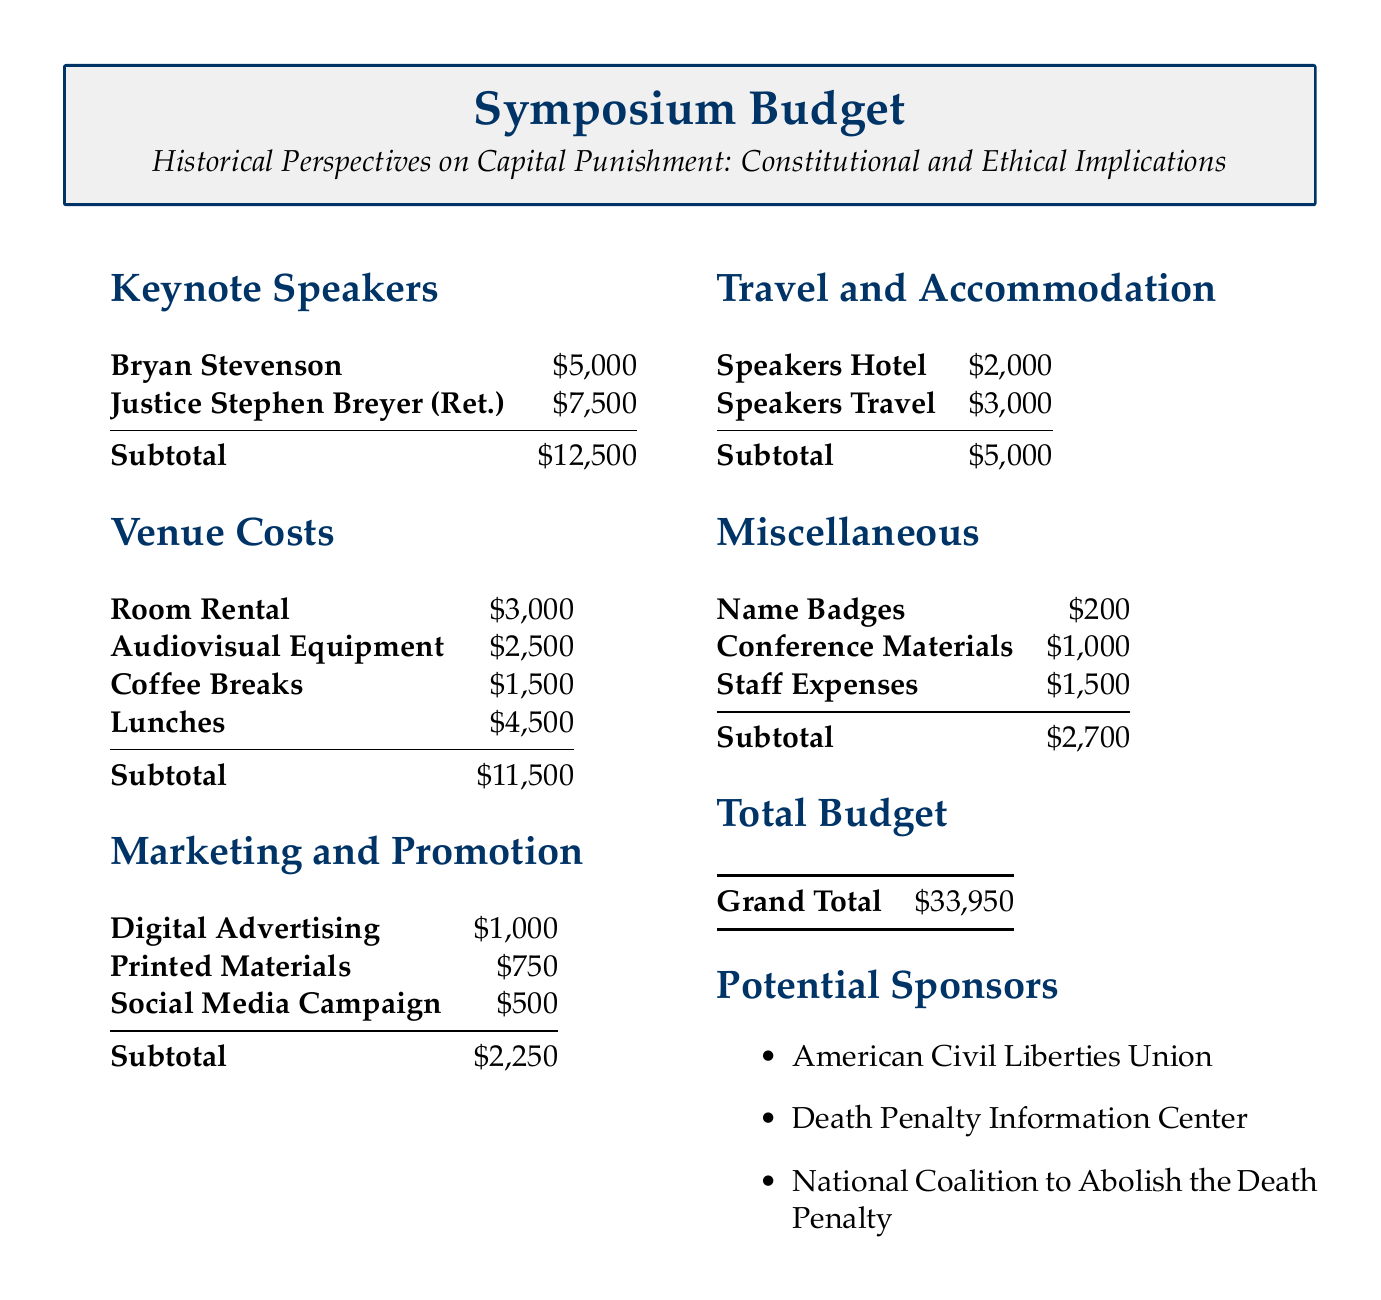What is the budget for keynote speakers? The budget for keynote speakers is a subtotal that includes payments for Bryan Stevenson and Justice Stephen Breyer, totaling $12,500.
Answer: $12,500 What is the largest line item in the venue costs? The largest line item in venue costs is the cost of lunches, which is specified as $4,500.
Answer: $4,500 How much is allocated for digital advertising? The document lists the cost allocated for digital advertising under marketing and promotion as $1,000.
Answer: $1,000 What is the total amount budgeted for miscellaneous expenses? The total amount budgeted for miscellaneous expenses is calculated from name badges, conference materials, and staff expenses, resulting in a subtotal of $2,700.
Answer: $2,700 Who are the potential sponsors listed in the budget? The document lists three potential sponsors: American Civil Liberties Union, Death Penalty Information Center, and National Coalition to Abolish the Death Penalty.
Answer: American Civil Liberties Union, Death Penalty Information Center, National Coalition to Abolish the Death Penalty What is the grand total of the symposium budget? The grand total of the symposium budget comprises all sections of the budget totaling $33,950.
Answer: $33,950 How much is budgeted for speakers' travel? The budget for speakers' travel is specified as $3,000 under the travel and accommodation section.
Answer: $3,000 What is the subtotal for marketing and promotion? The subtotal for marketing and promotion sums the costs of digital advertising, printed materials, and social media campaign, totaling $2,250.
Answer: $2,250 What item follows the coffee breaks in the venue costs? The item following coffee breaks in the venue costs is lunches, which are listed at $4,500.
Answer: Lunches 